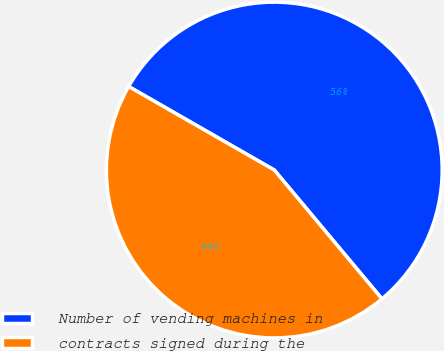<chart> <loc_0><loc_0><loc_500><loc_500><pie_chart><fcel>Number of vending machines in<fcel>contracts signed during the<nl><fcel>55.63%<fcel>44.37%<nl></chart> 